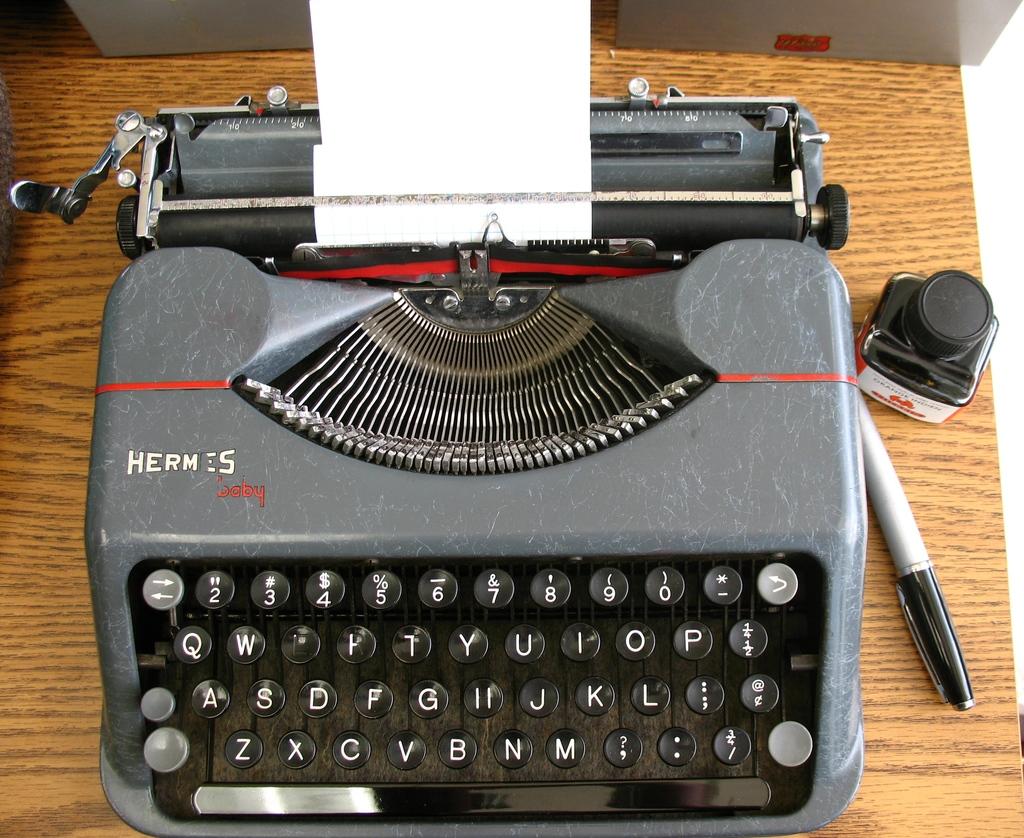What is the brand name of the typewriter?
Your answer should be compact. Hermes. 